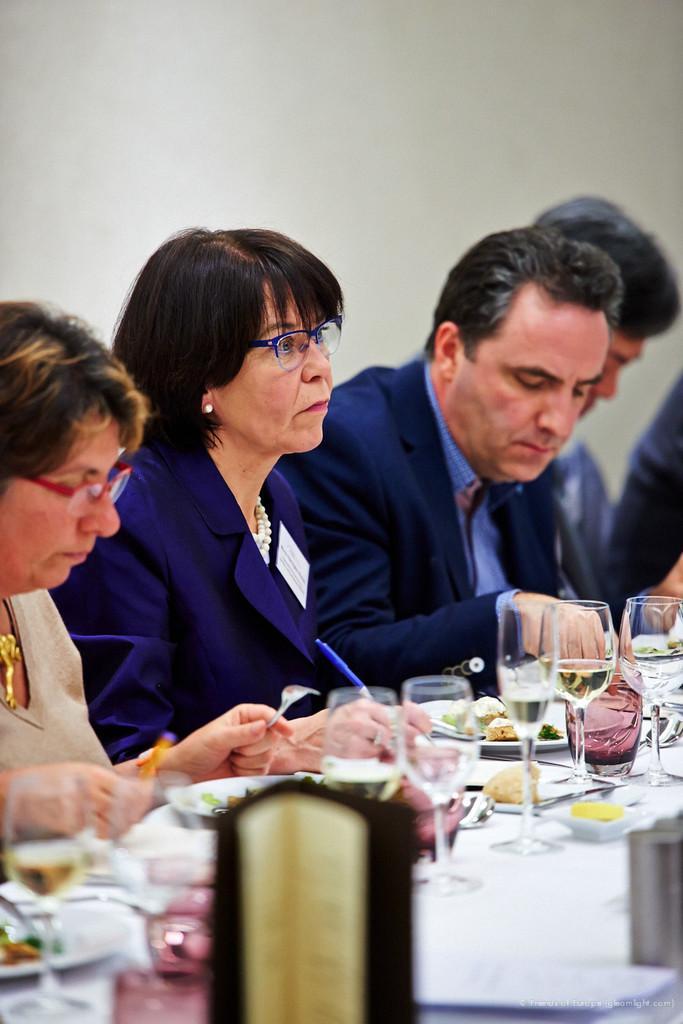Please provide a concise description of this image. In this image I can see in there is a group of people who are sitting on a chair in front of a table and eating food. On the table I can see there are few glasses, plate and other objects on it. 